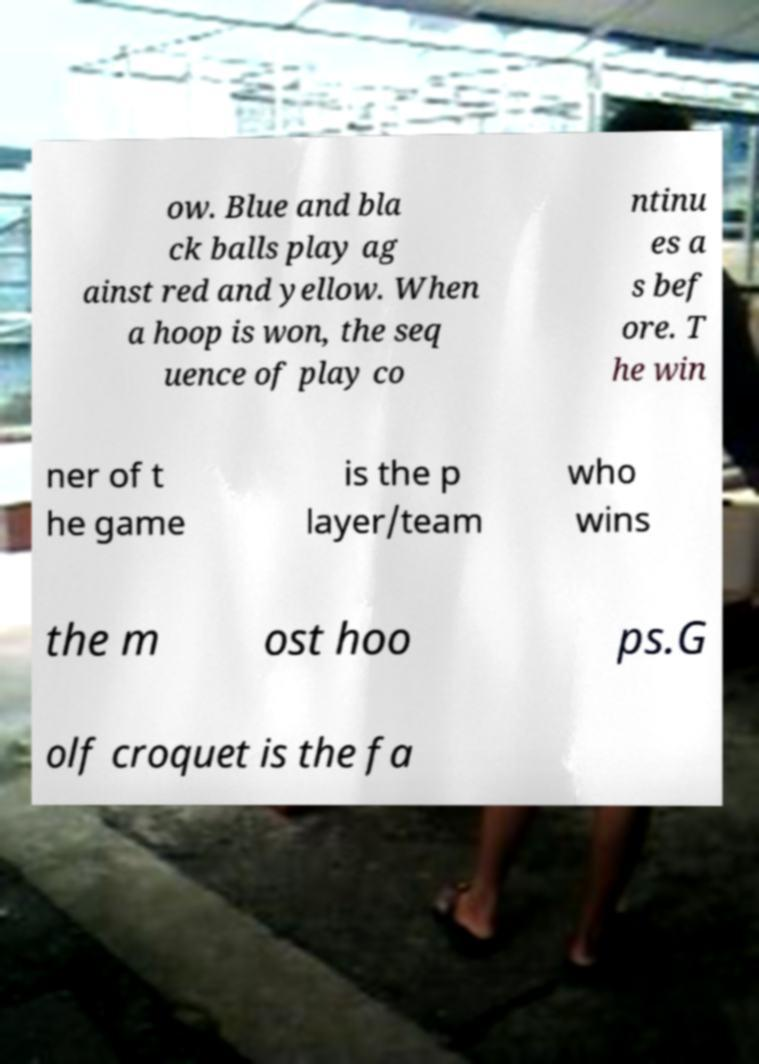I need the written content from this picture converted into text. Can you do that? ow. Blue and bla ck balls play ag ainst red and yellow. When a hoop is won, the seq uence of play co ntinu es a s bef ore. T he win ner of t he game is the p layer/team who wins the m ost hoo ps.G olf croquet is the fa 